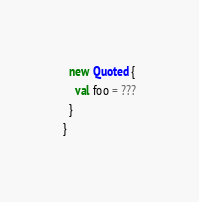Convert code to text. <code><loc_0><loc_0><loc_500><loc_500><_Scala_>  new Quoted {
    val foo = ???
  }
}
</code> 